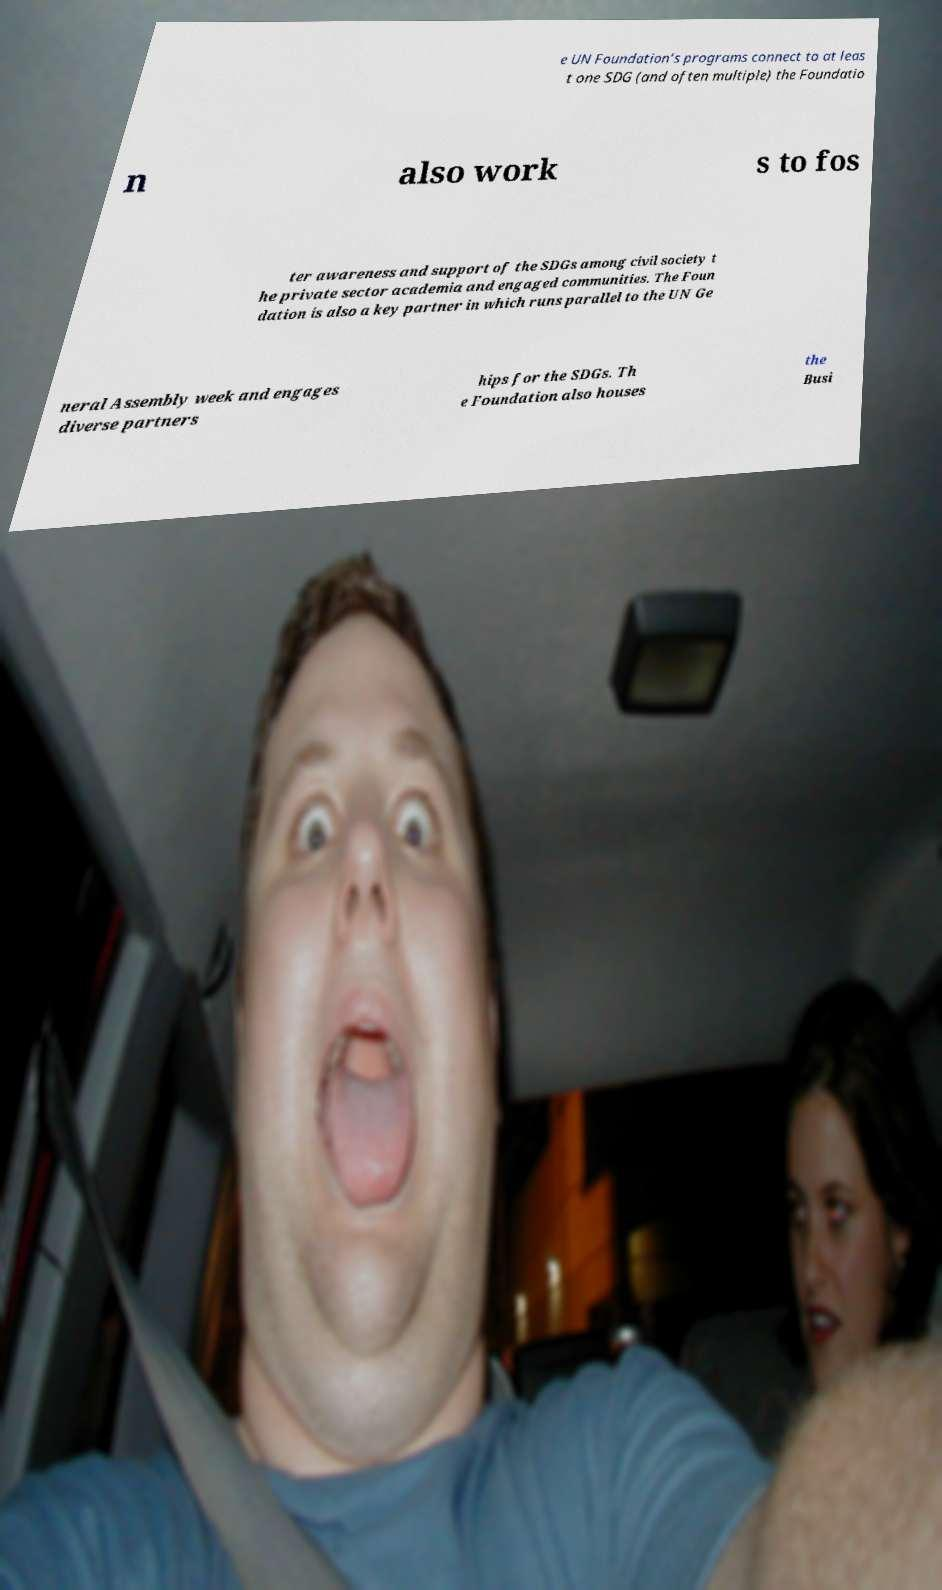Please identify and transcribe the text found in this image. e UN Foundation’s programs connect to at leas t one SDG (and often multiple) the Foundatio n also work s to fos ter awareness and support of the SDGs among civil society t he private sector academia and engaged communities. The Foun dation is also a key partner in which runs parallel to the UN Ge neral Assembly week and engages diverse partners hips for the SDGs. Th e Foundation also houses the Busi 